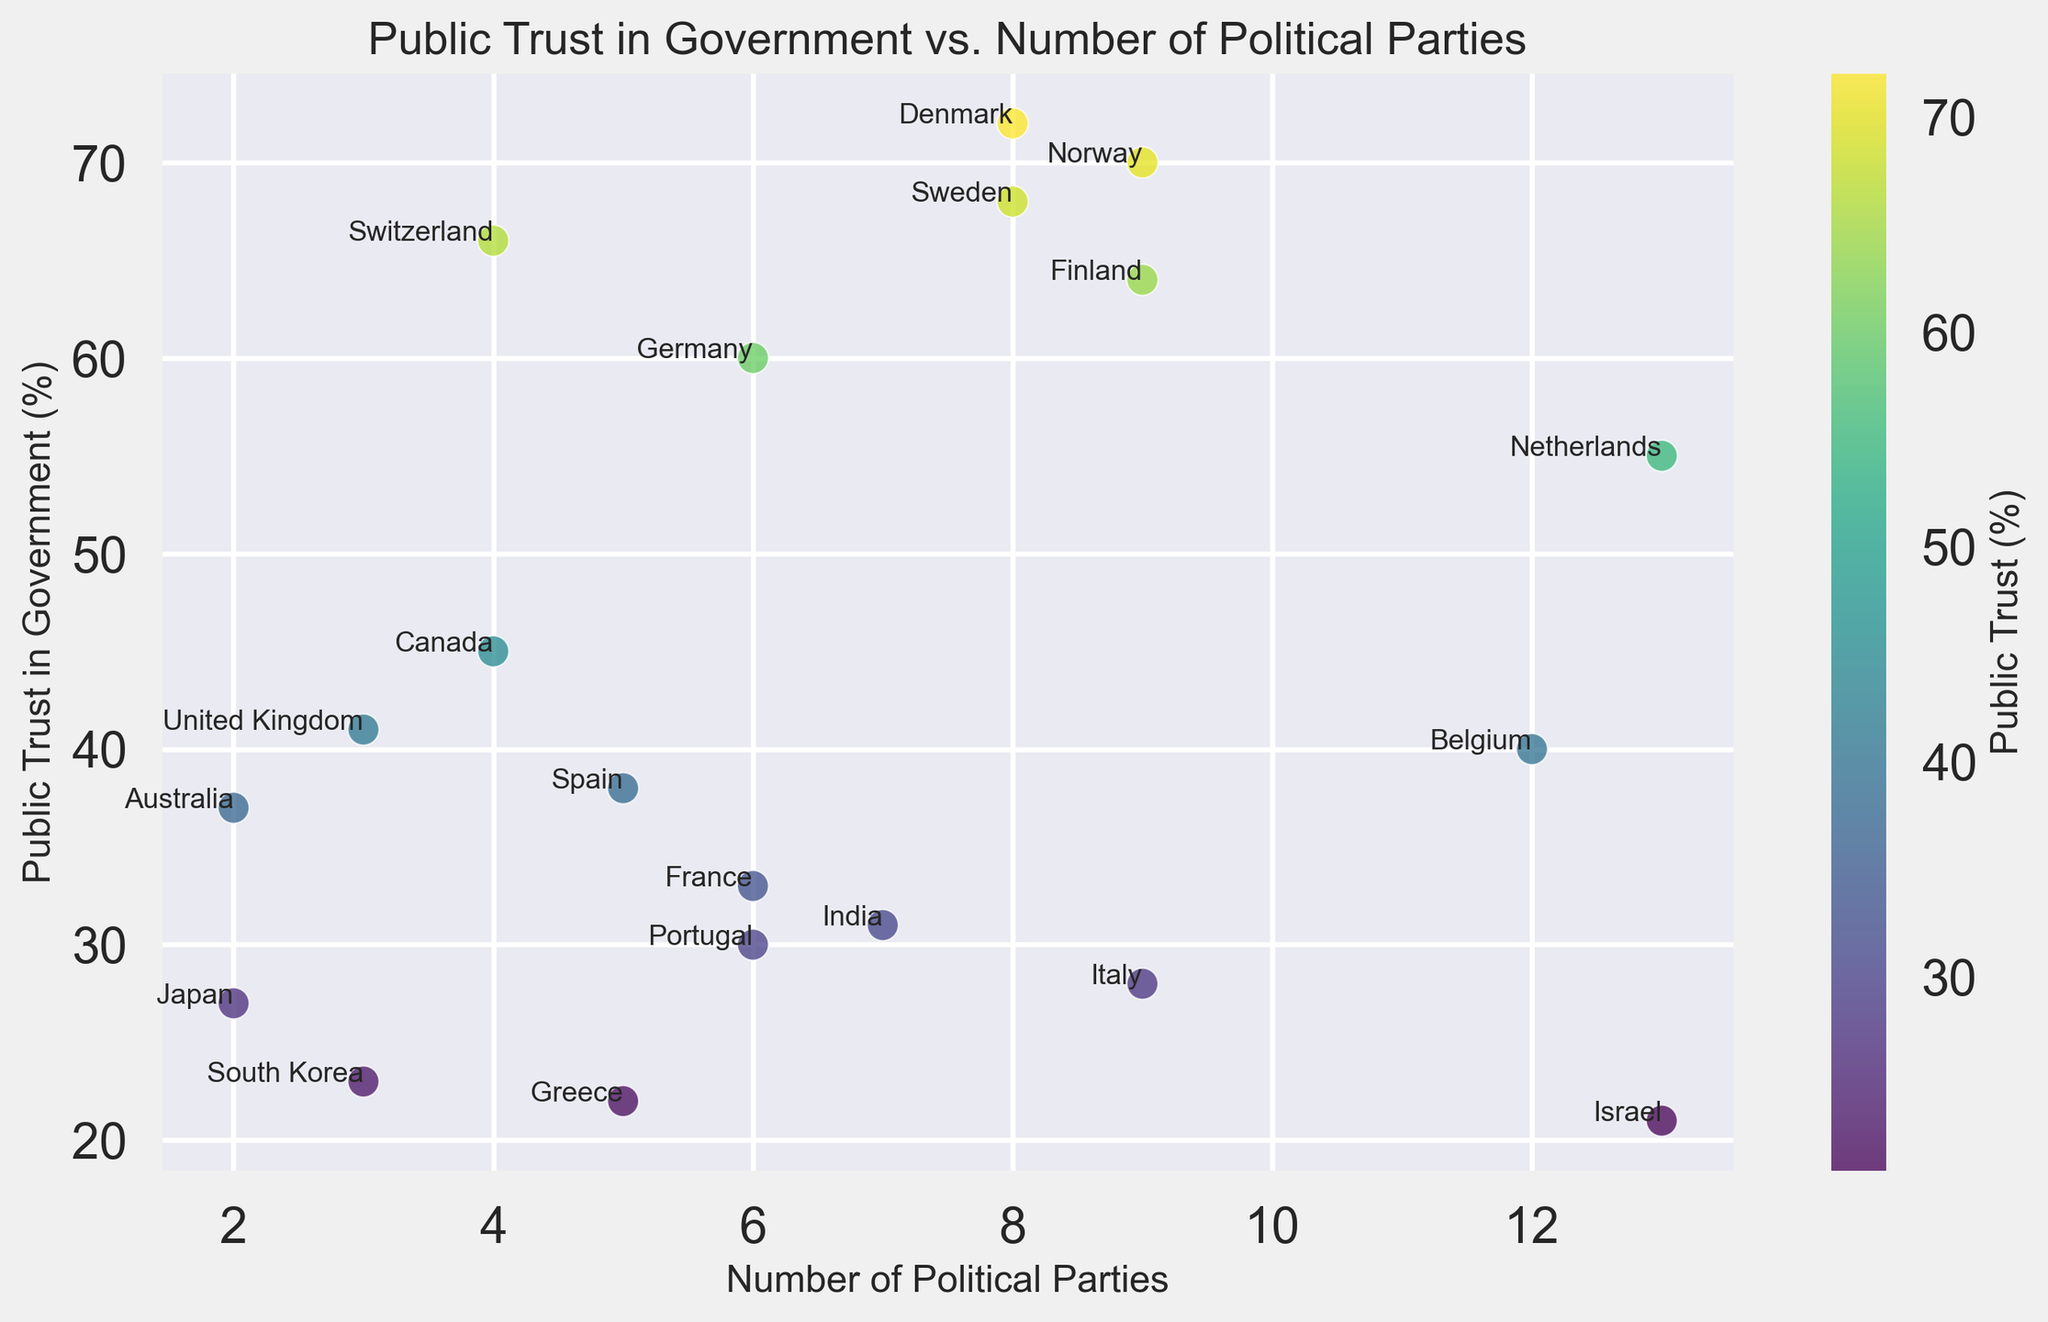Which country has the highest public trust in government? Refer to the highest point on the y-axis, which represents the public trust percentage. The country at this highest point is Denmark.
Answer: Denmark Which country has the lowest public trust in government? Refer to the lowest point on the y-axis, which represents the public trust percentage. The country at this lowest point is Israel.
Answer: Israel Which countries have exactly 13 political parties in their parliament? Look for the points on the x-axis where the number of political parties is 13. The corresponding countries are annotated next to these points. The countries are Netherlands and Israel.
Answer: Netherlands and Israel Among Germany and France, which country has higher public trust in government? Compare the y-axis values for the points of Germany and France on the chart. Germany has a higher public trust percentage (60) compared to France (33).
Answer: Germany Are there more countries with fewer than 5 political parties or more than 5 political parties? Count the number of countries having fewer than 5 political parties and those having more than 5. With fewer than 5: 5 countries (Australia, Canada, UK, Japan, and South Korea), With more than 5: 13 countries (all others).
Answer: More countries have more than 5 political parties What is the average public trust in government for countries with exactly 6 political parties? Identify countries with 6 political parties (Germany, France, Portugal). Sum their trust values (60 + 33 + 30) = 123, and divide by the number of countries (3). The average is 41%.
Answer: 41% Compare the public trust in government between the country with the most political parties and the country with the least. The country with the most parties (13) has Netherlands (55) and Israel (21). The country with the least parties (2) has Australia (37) and Japan (27). The comparisons are 55 vs 37 and 21 vs 27.
Answer: Netherlands has higher trust than Australia, Israel has lower trust than Japan Which country has the closest value to the median public trust in government? First, list all trust values: 72, 60, 55, 68, 64, 45, 37, 41, 33, 28, 38, 27, 23, 31, 21, 40, 66, 70, 30, 22. Median is the middle value in the sorted list. Sorted values: 21, 22, 23, 27, 28, 30, 31, 33, 37, 38, 40, 41, 45, 55, 60, 64, 66, 68, 70, 72. Median is between 38 and 40, which is 39. Closest country to 39 is Israel (40).
Answer: Israel 